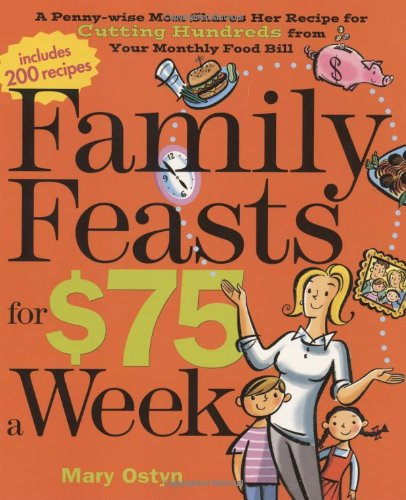What are some of the key ingredients mentioned frequently in this book for budget meals? Key ingredients often mentioned include beans, rice, and vegetables, which are not only affordable but also versatile and nutritious. 